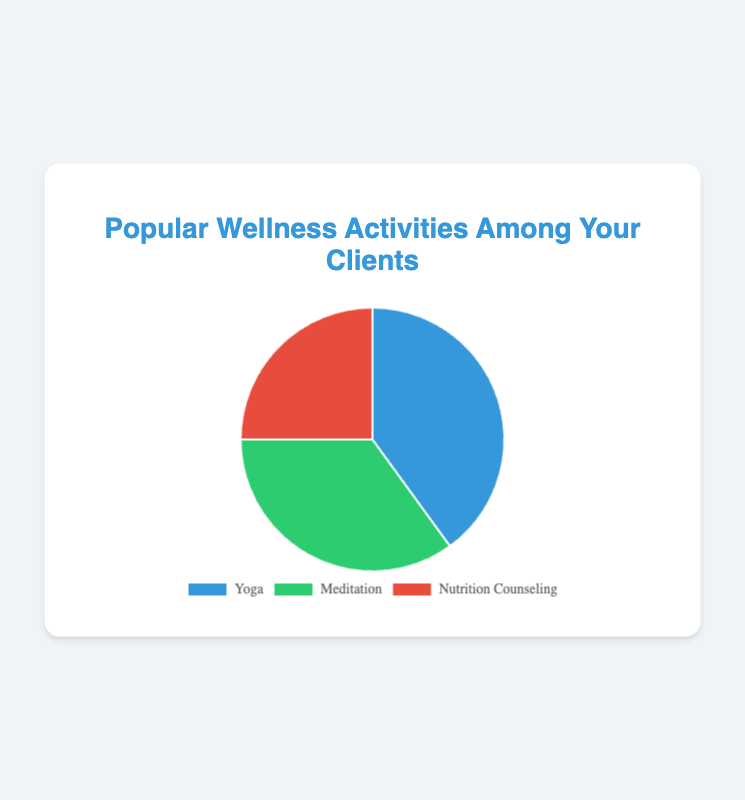What's the most popular wellness activity among your clients? The chart shows that Yoga has the highest percentage slice at 40%, making it the most popular activity.
Answer: Yoga What's the difference in percentage between the most and the least popular activities? The most popular activity is Yoga at 40%, and the least popular is Nutrition Counseling at 25%. The difference is 40% - 25% = 15%.
Answer: 15% Which activity represents 35% of client participation? By looking at the pie chart, the slice representing 35% is labeled as Meditation.
Answer: Meditation What percentage of clients participate in activities other than Yoga? The percentages for Meditation and Nutrition Counseling are 35% and 25%, respectively. Adding these gives 35% + 25% = 60%.
Answer: 60% Is Yoga more popular than Meditation and Nutrition Counseling combined? Yoga has a 40% participation rate. Meditation and Nutrition Counseling combined have 35% + 25% = 60%. Since 40% is less than 60%, Yoga is not more popular than the combined activities.
Answer: No Which activity is indicated by the green color on the chart? The green color represents the Meditation slice in the pie chart.
Answer: Meditation How many percentage points more popular is Yoga compared to Meditation? Yoga is 40% and Meditation is 35%. The difference is 40% - 35% = 5%.
Answer: 5% Which two activities combined make up exactly 60% of client participation? Meditation at 35% and Nutrition Counseling at 25% add up to 35% + 25% = 60%.
Answer: Meditation and Nutrition Counseling What is the average percentage of client participation across all three activities? The percentages are 40% for Yoga, 35% for Meditation, and 25% for Nutrition Counseling. The average is (40% + 35% + 25%) / 3 = 100% / 3 ≈ 33.33%.
Answer: 33.33% Which activity is represented by the blue color in the chart? The blue color is used for the Yoga slice in the pie chart.
Answer: Yoga 